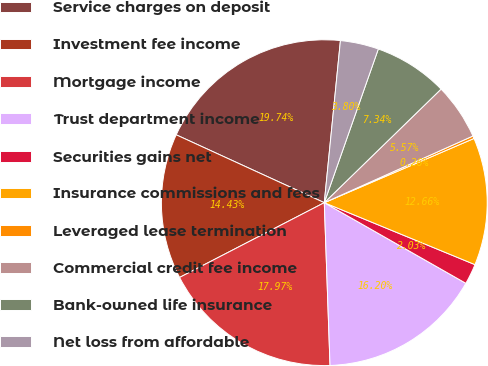<chart> <loc_0><loc_0><loc_500><loc_500><pie_chart><fcel>Service charges on deposit<fcel>Investment fee income<fcel>Mortgage income<fcel>Trust department income<fcel>Securities gains net<fcel>Insurance commissions and fees<fcel>Leveraged lease termination<fcel>Commercial credit fee income<fcel>Bank-owned life insurance<fcel>Net loss from affordable<nl><fcel>19.74%<fcel>14.43%<fcel>17.97%<fcel>16.2%<fcel>2.03%<fcel>12.66%<fcel>0.26%<fcel>5.57%<fcel>7.34%<fcel>3.8%<nl></chart> 